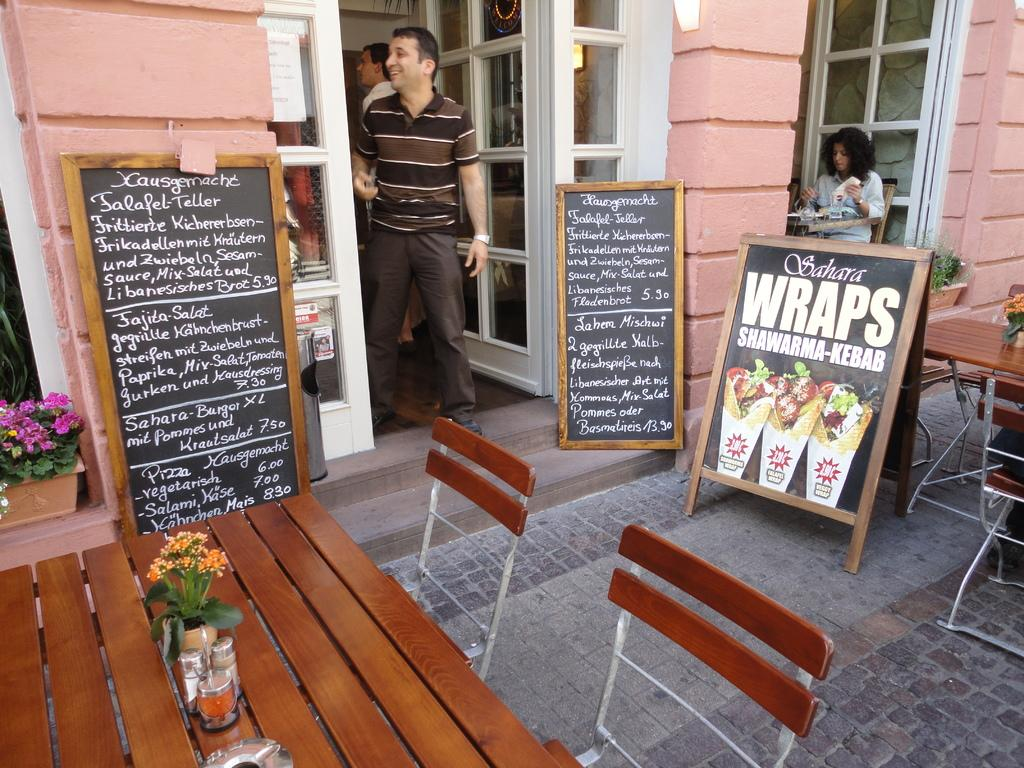How many blackboards are present in the image? There are two blackboards in the image. What is written on the blackboards? There is writing on the blackboards. What is the position of the person in the image? There is a person standing between the blackboards. What type of furniture is present in the image? There is a table and chairs in the image. What type of cork can be seen on the blackboards in the image? There is no cork present on the blackboards in the image. Can you tell me how many zebras are visible in the image? There are no zebras present in the image. 